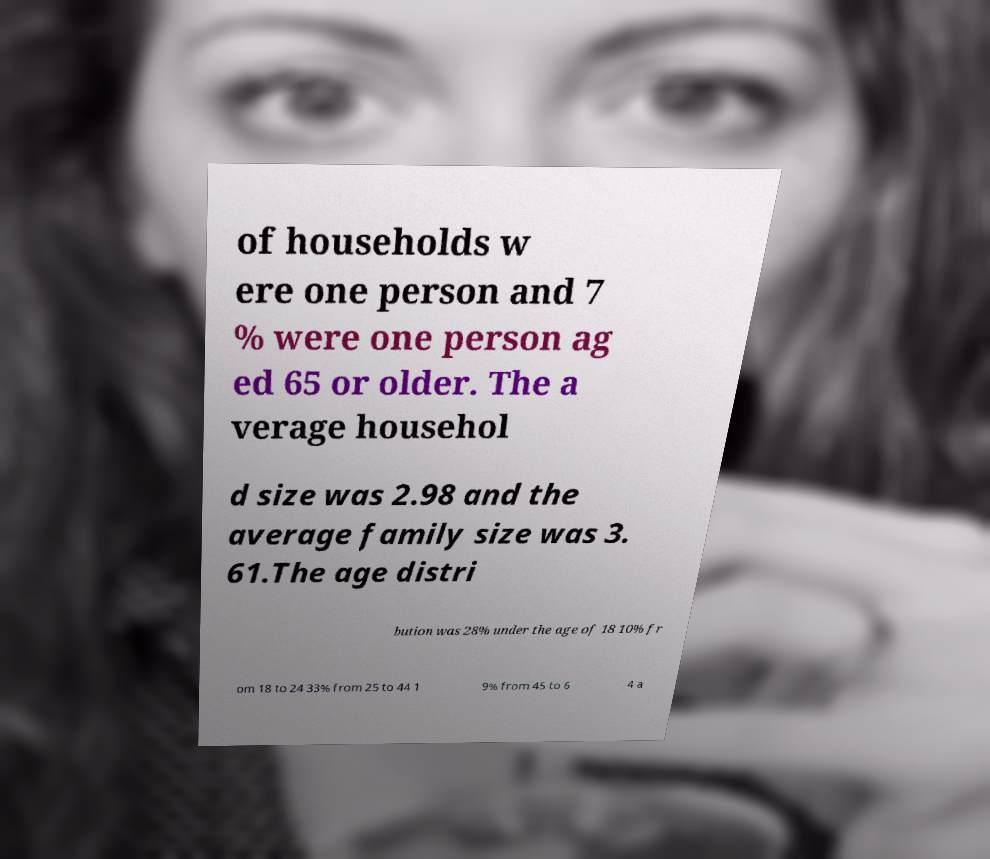Could you assist in decoding the text presented in this image and type it out clearly? of households w ere one person and 7 % were one person ag ed 65 or older. The a verage househol d size was 2.98 and the average family size was 3. 61.The age distri bution was 28% under the age of 18 10% fr om 18 to 24 33% from 25 to 44 1 9% from 45 to 6 4 a 